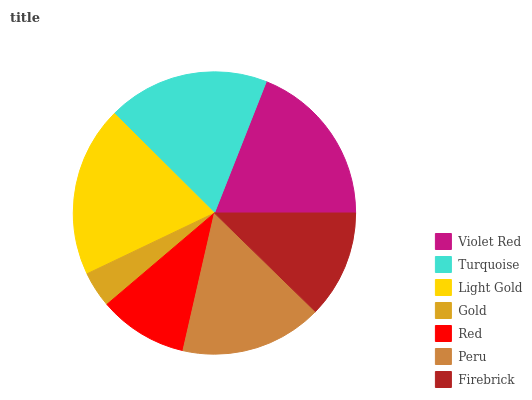Is Gold the minimum?
Answer yes or no. Yes. Is Light Gold the maximum?
Answer yes or no. Yes. Is Turquoise the minimum?
Answer yes or no. No. Is Turquoise the maximum?
Answer yes or no. No. Is Violet Red greater than Turquoise?
Answer yes or no. Yes. Is Turquoise less than Violet Red?
Answer yes or no. Yes. Is Turquoise greater than Violet Red?
Answer yes or no. No. Is Violet Red less than Turquoise?
Answer yes or no. No. Is Peru the high median?
Answer yes or no. Yes. Is Peru the low median?
Answer yes or no. Yes. Is Firebrick the high median?
Answer yes or no. No. Is Violet Red the low median?
Answer yes or no. No. 